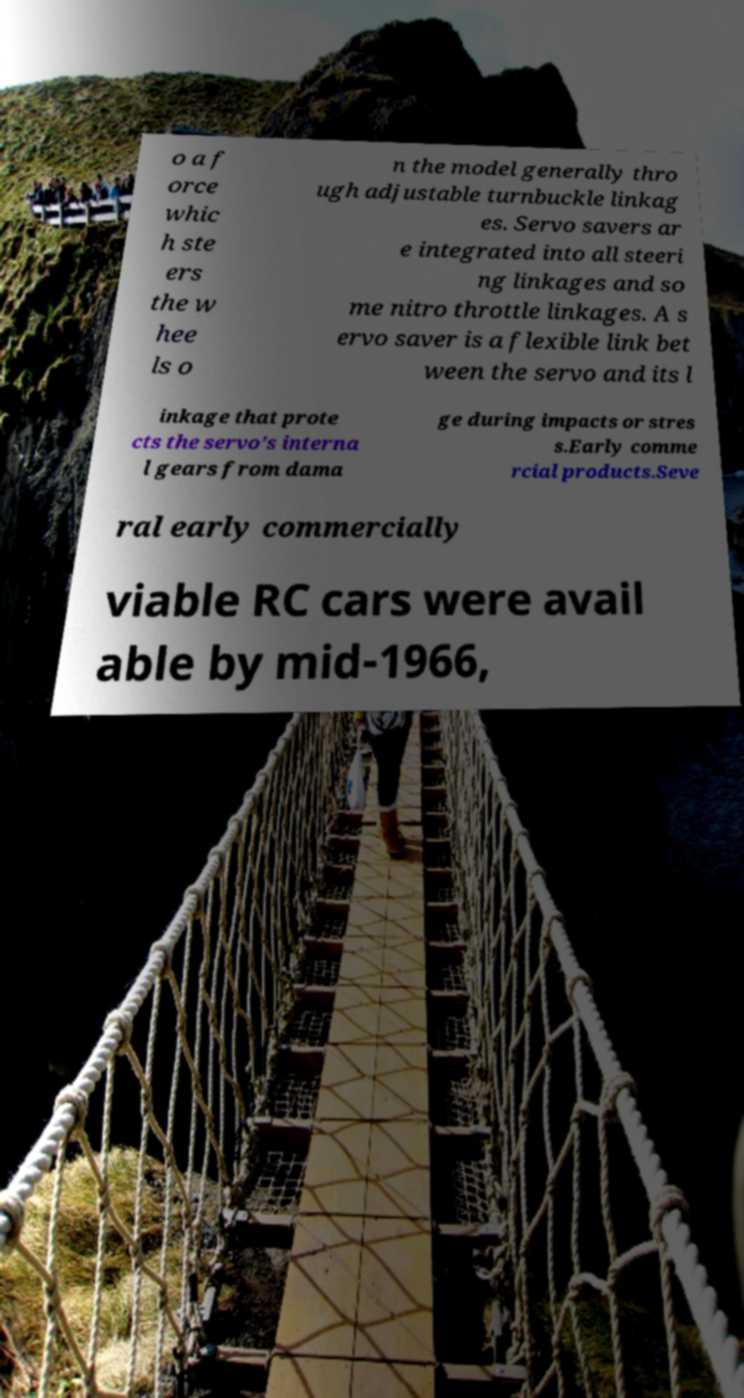Please read and relay the text visible in this image. What does it say? o a f orce whic h ste ers the w hee ls o n the model generally thro ugh adjustable turnbuckle linkag es. Servo savers ar e integrated into all steeri ng linkages and so me nitro throttle linkages. A s ervo saver is a flexible link bet ween the servo and its l inkage that prote cts the servo's interna l gears from dama ge during impacts or stres s.Early comme rcial products.Seve ral early commercially viable RC cars were avail able by mid-1966, 